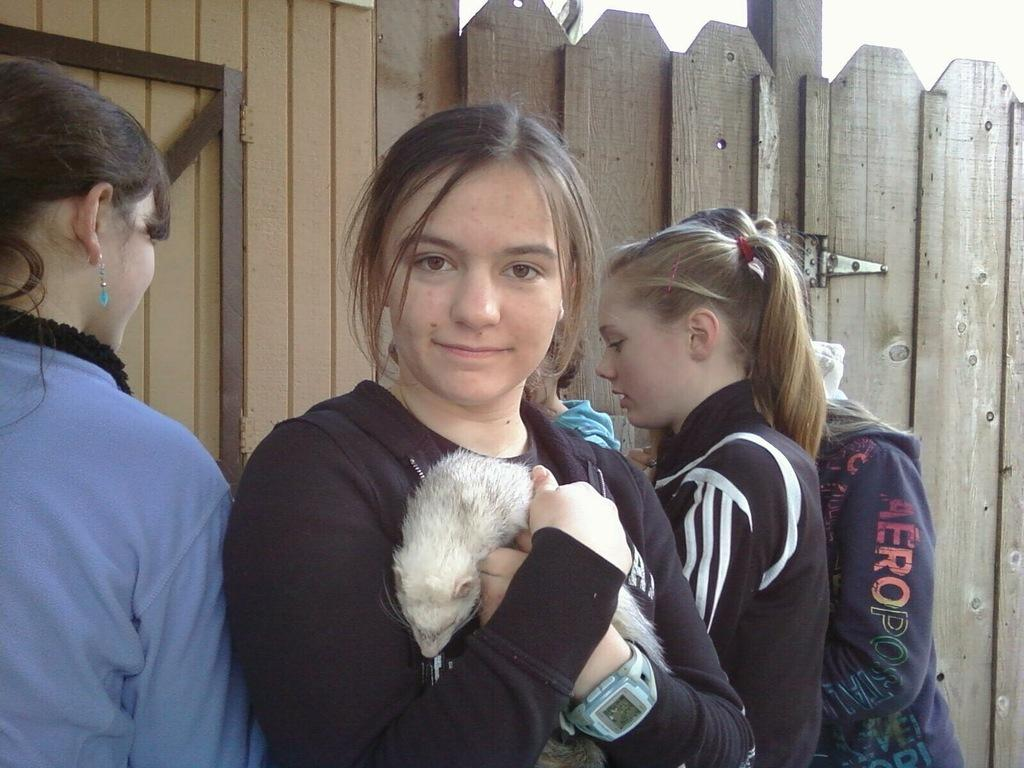How many people are in the image? There are a few persons in the image. What is one person doing with an animal? One person is holding an animal. What can be seen in the background of the image? There is a wall and metal rods in the background of the image. What flavor of ice cream is the person holding the animal eating? There is no ice cream present in the image, so it cannot be determined if the person is eating any. 